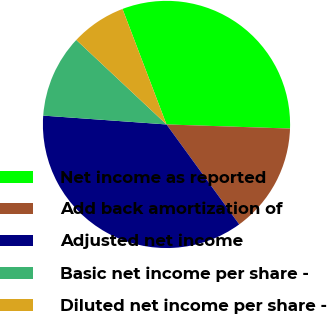Convert chart to OTSL. <chart><loc_0><loc_0><loc_500><loc_500><pie_chart><fcel>Net income as reported<fcel>Add back amortization of<fcel>Adjusted net income<fcel>Basic net income per share -<fcel>Diluted net income per share -<nl><fcel>31.32%<fcel>14.46%<fcel>36.15%<fcel>10.84%<fcel>7.23%<nl></chart> 